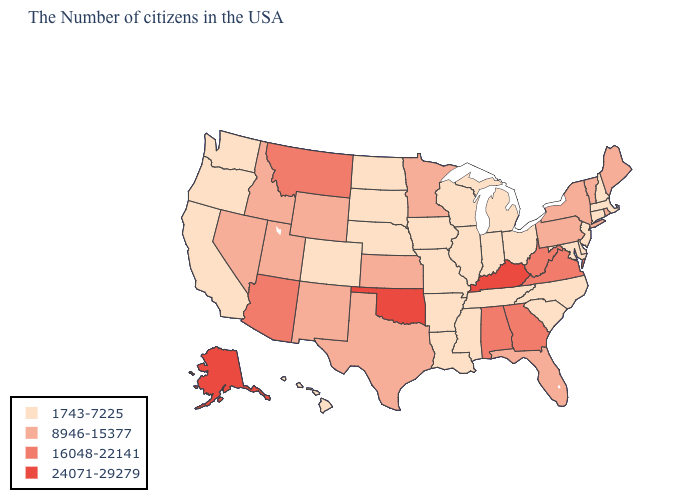Name the states that have a value in the range 16048-22141?
Concise answer only. Virginia, West Virginia, Georgia, Alabama, Montana, Arizona. What is the value of Wisconsin?
Keep it brief. 1743-7225. What is the value of Massachusetts?
Concise answer only. 1743-7225. Which states have the lowest value in the South?
Keep it brief. Delaware, Maryland, North Carolina, South Carolina, Tennessee, Mississippi, Louisiana, Arkansas. What is the lowest value in the USA?
Answer briefly. 1743-7225. What is the lowest value in the USA?
Quick response, please. 1743-7225. Does Arizona have the lowest value in the USA?
Give a very brief answer. No. How many symbols are there in the legend?
Answer briefly. 4. What is the value of Pennsylvania?
Concise answer only. 8946-15377. What is the lowest value in states that border Arizona?
Quick response, please. 1743-7225. Name the states that have a value in the range 8946-15377?
Be succinct. Maine, Rhode Island, Vermont, New York, Pennsylvania, Florida, Minnesota, Kansas, Texas, Wyoming, New Mexico, Utah, Idaho, Nevada. What is the value of Colorado?
Answer briefly. 1743-7225. Name the states that have a value in the range 1743-7225?
Quick response, please. Massachusetts, New Hampshire, Connecticut, New Jersey, Delaware, Maryland, North Carolina, South Carolina, Ohio, Michigan, Indiana, Tennessee, Wisconsin, Illinois, Mississippi, Louisiana, Missouri, Arkansas, Iowa, Nebraska, South Dakota, North Dakota, Colorado, California, Washington, Oregon, Hawaii. What is the value of Kansas?
Answer briefly. 8946-15377. What is the highest value in states that border Pennsylvania?
Concise answer only. 16048-22141. 